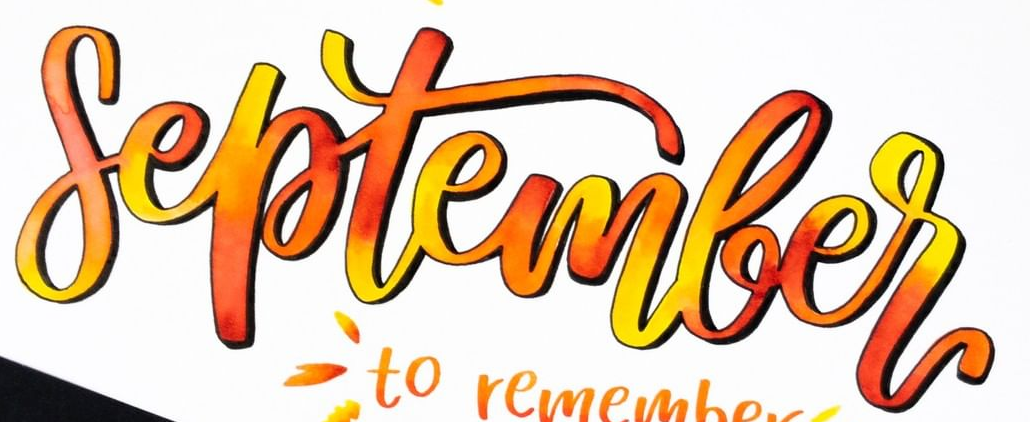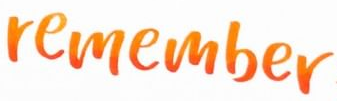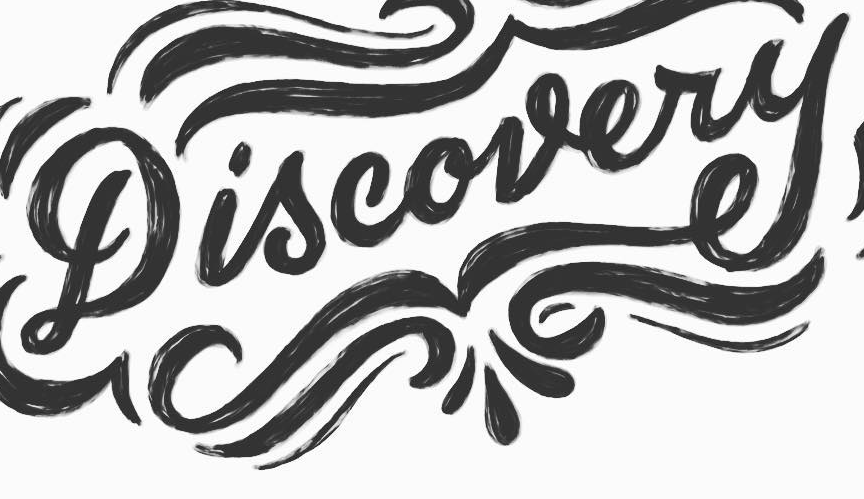What words are shown in these images in order, separated by a semicolon? September; remember; Discovery 